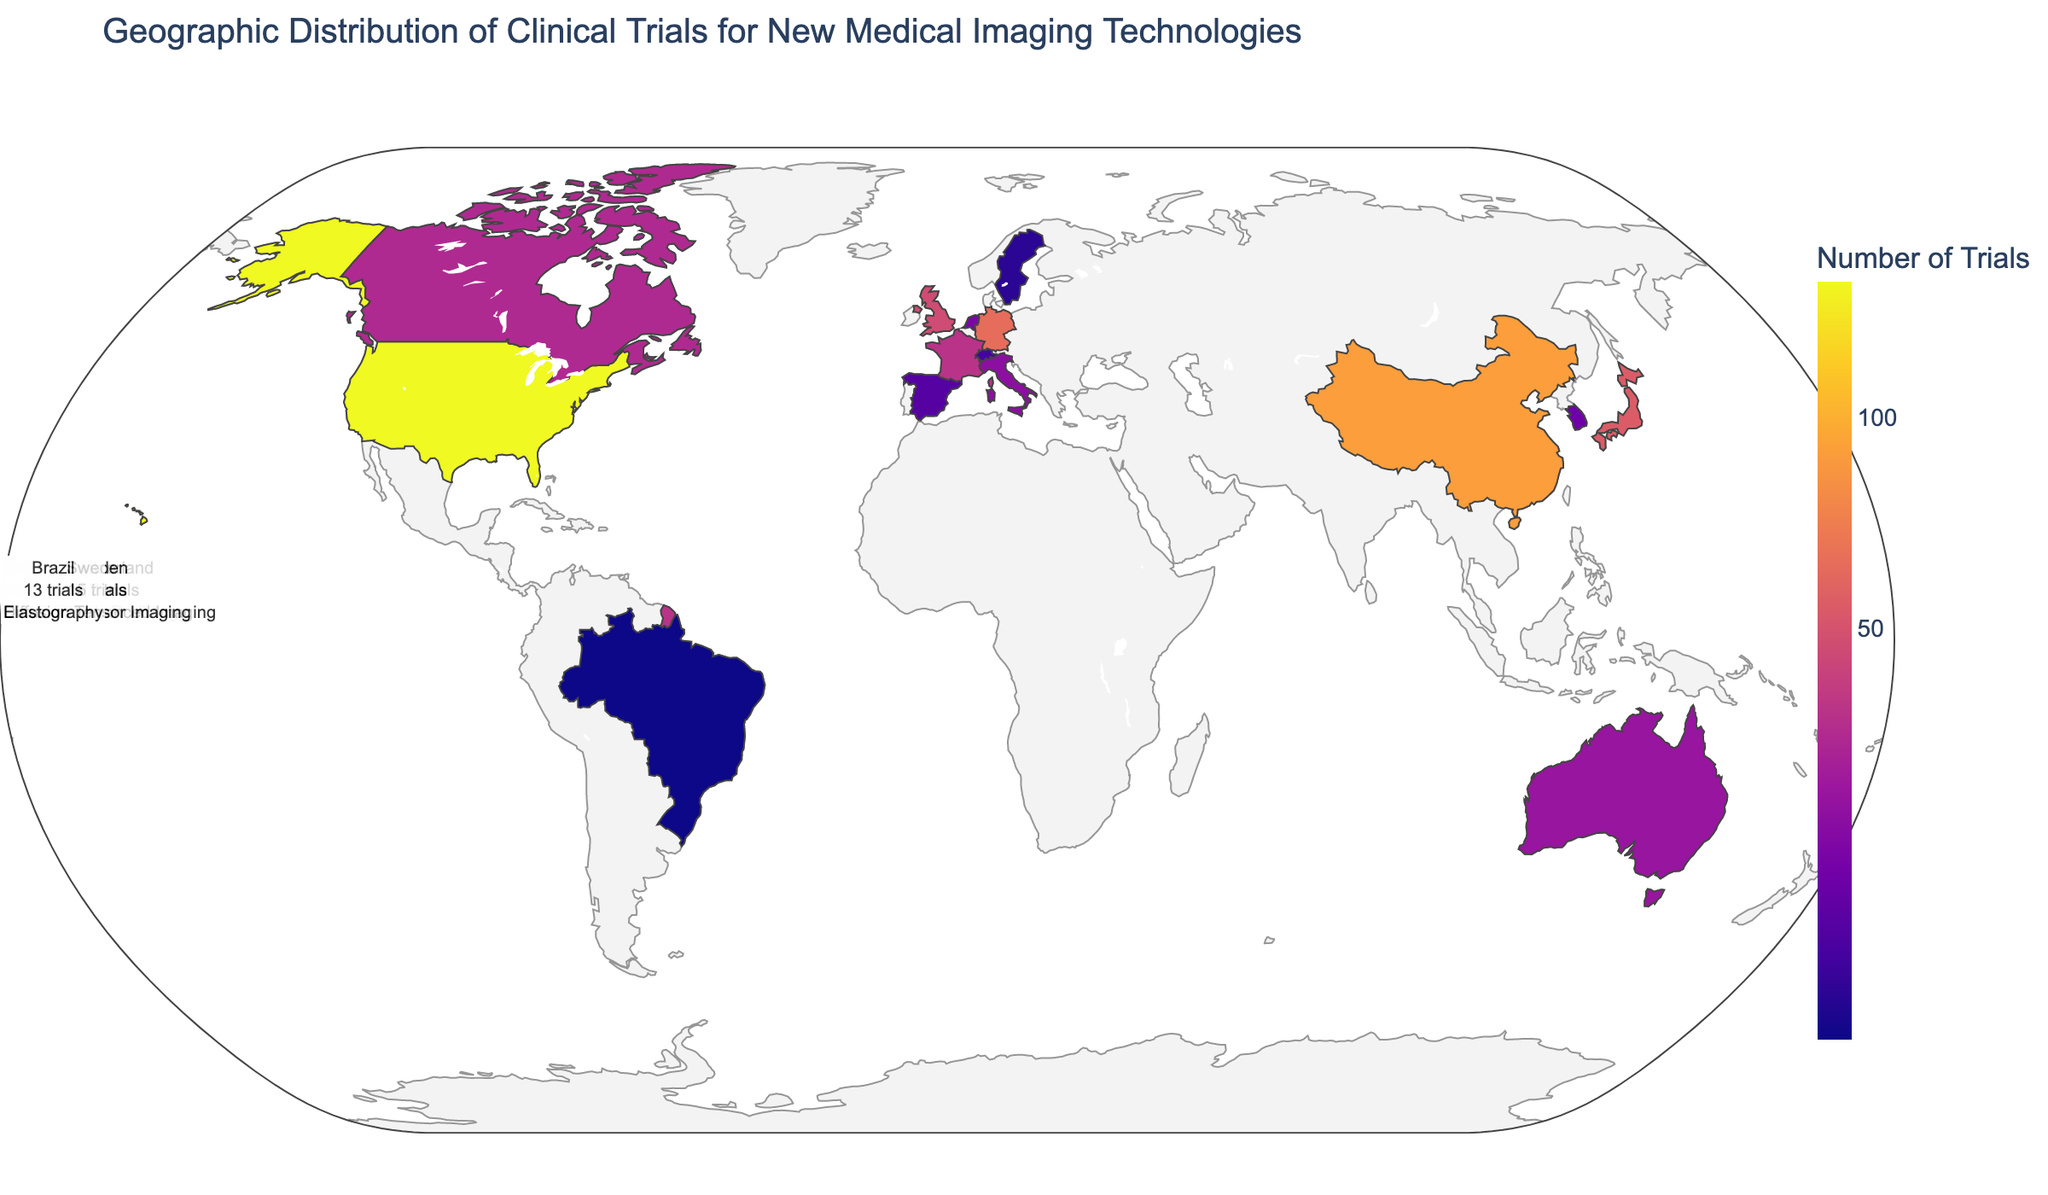How many clinical trials were conducted in the United States? Look for the country's name 'United States' on the geographic plot and refer to the number of trials associated with it.
Answer: 156 Which country has the primary technology focus on PET Scanning? Refer to the list of countries and match the 'Primary Technology Focus' field with 'PET Scanning'.
Answer: Germany What is the color scale used to represent the number of trials? The color scale used to represent data can be determined by examining the color legend and description in the plot.
Answer: Plasma What is the total number of clinical trials in the top three countries combined? Sum the number of trials for the top three countries: United States (156), China (89), and Germany (62). Calculation: 156 + 89 + 62 = 307
Answer: 307 Which country has the lowest number of trials for new medical imaging technologies? Identify all countries plotted and locate the one with the smallest number of clinical trials.
Answer: Brazil Which countries have a higher number of trials than the United Kingdom? Compare the number of trials for the United Kingdom (47) with those of other countries and identify the ones with higher values.
Answer: United States, China, Germany, Japan What are the top five countries in terms of the number of clinical trials? Rank the countries based on the number of clinical trials and list the top five.
Answer: United States, China, Germany, Japan, United Kingdom What is the median number of trials among all listed countries? Sort the list of trial numbers and find the middle value. Trial counts sorted: 13, 15, 17, 19, 22, 24, 27, 29, 35, 38, 47, 54, 62, 89, 156. The median is the middle value: 29
Answer: 29 What is the predominant medical imaging technology focus in Canada? Find 'Canada' on the plot and refer to the associated 'Primary Technology Focus'.
Answer: Optical Imaging 